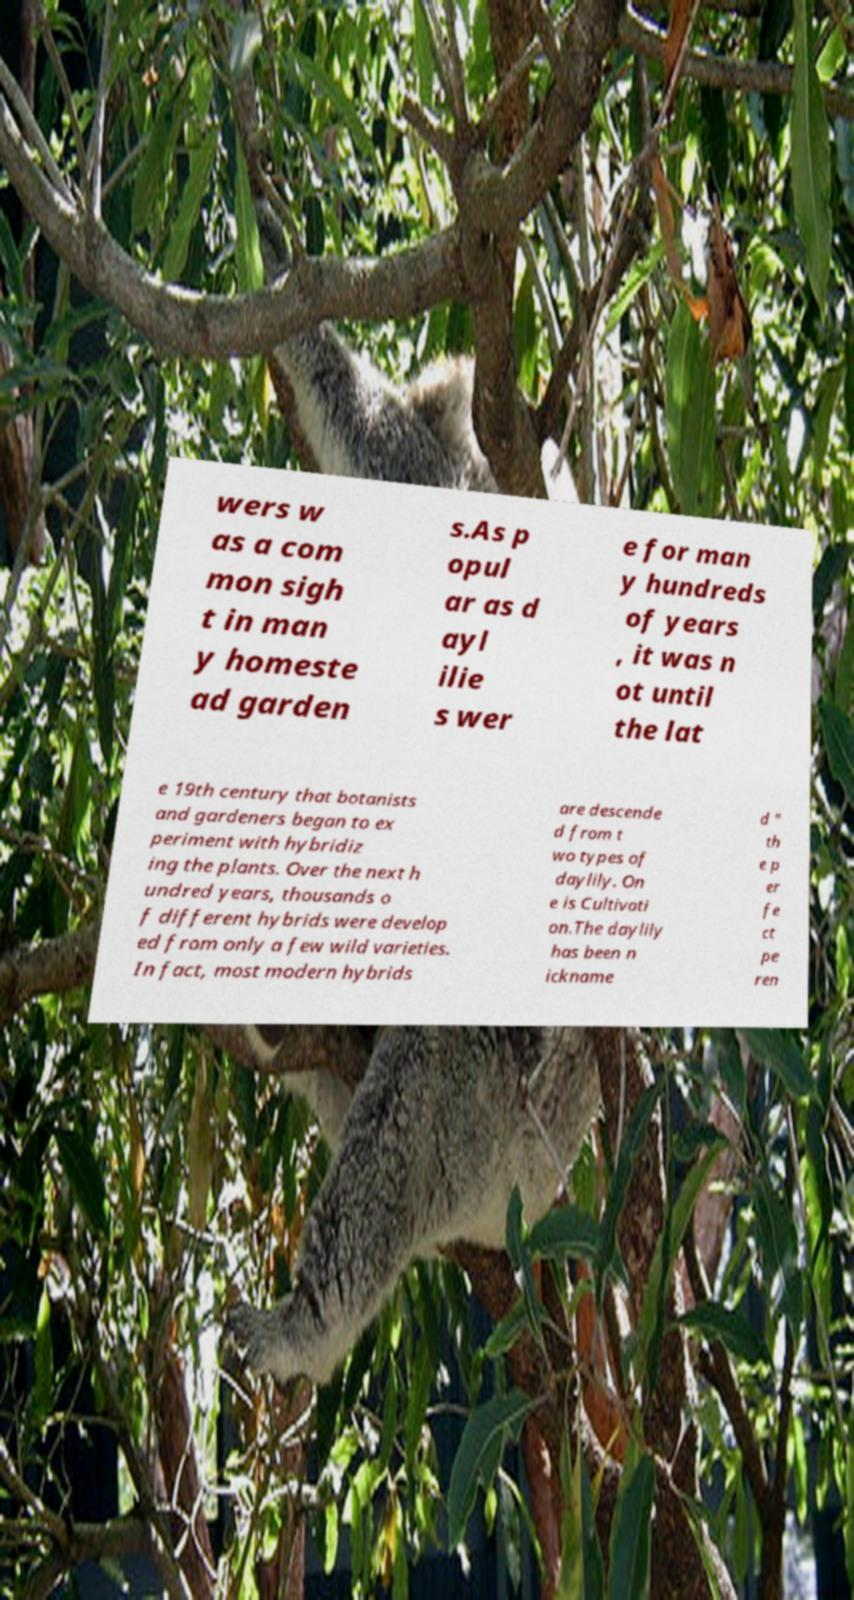There's text embedded in this image that I need extracted. Can you transcribe it verbatim? wers w as a com mon sigh t in man y homeste ad garden s.As p opul ar as d ayl ilie s wer e for man y hundreds of years , it was n ot until the lat e 19th century that botanists and gardeners began to ex periment with hybridiz ing the plants. Over the next h undred years, thousands o f different hybrids were develop ed from only a few wild varieties. In fact, most modern hybrids are descende d from t wo types of daylily. On e is Cultivati on.The daylily has been n ickname d " th e p er fe ct pe ren 